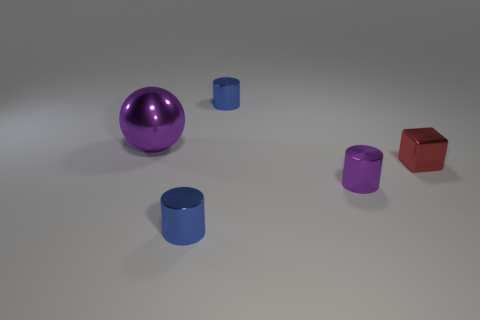There is a blue object behind the purple shiny thing that is on the right side of the shiny ball; what size is it?
Your answer should be very brief. Small. How many yellow things are tiny metallic objects or shiny cylinders?
Your answer should be very brief. 0. Is the number of small shiny things right of the small red object less than the number of shiny things that are in front of the purple metallic cylinder?
Offer a terse response. Yes. Does the purple shiny cylinder have the same size as the cylinder behind the big purple shiny ball?
Make the answer very short. Yes. What number of blue things have the same size as the purple cylinder?
Keep it short and to the point. 2. How many big objects are either purple shiny spheres or brown matte blocks?
Provide a succinct answer. 1. Are any tiny objects visible?
Your answer should be very brief. Yes. Is the number of small metal blocks that are behind the small block greater than the number of tiny blue metal cylinders that are right of the small purple metallic object?
Give a very brief answer. No. There is a tiny shiny cylinder that is behind the purple object that is behind the small purple metal object; what color is it?
Your answer should be compact. Blue. Are there any big shiny balls that have the same color as the tiny block?
Make the answer very short. No. 